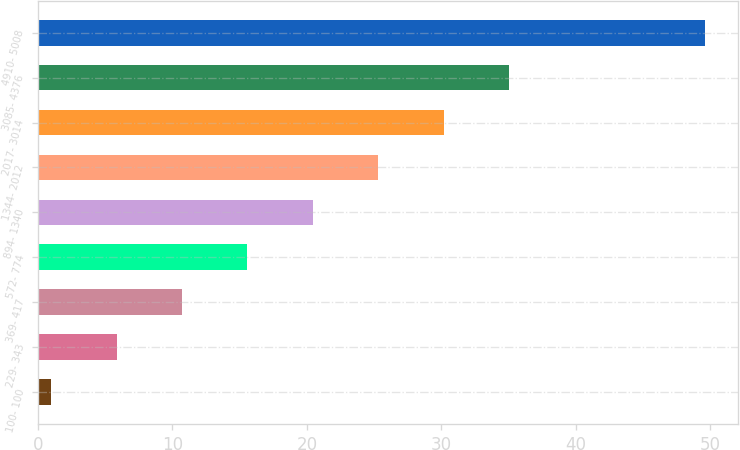Convert chart to OTSL. <chart><loc_0><loc_0><loc_500><loc_500><bar_chart><fcel>100- 100<fcel>229- 343<fcel>369- 417<fcel>572- 774<fcel>894- 1340<fcel>1344- 2012<fcel>2017- 3014<fcel>3085- 4376<fcel>4910- 5008<nl><fcel>1<fcel>5.86<fcel>10.72<fcel>15.58<fcel>20.44<fcel>25.3<fcel>30.16<fcel>35.02<fcel>49.58<nl></chart> 